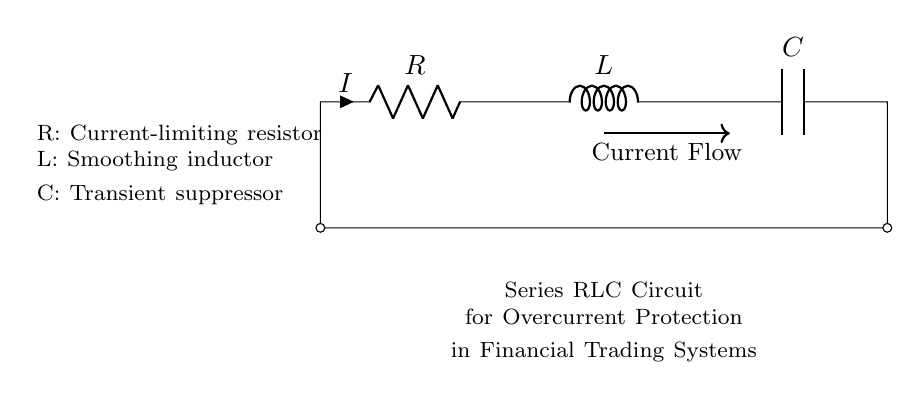What are the components in the circuit? The components are a resistor, an inductor, and a capacitor, which are indicated as R, L, and C in the circuit diagram.
Answer: Resistor, Inductor, Capacitor What is the function of the resistor in this circuit? The resistor (R) is labeled as a current-limiting resistor, which means it restricts the amount of current flowing through the circuit to prevent overcurrent conditions.
Answer: Current-limiting What is the role of the inductor in this circuit? The inductor (L) is described as a smoothing inductor, functioning to smooth out current variations and reduce ripples in the current flow.
Answer: Smoothing How does the capacitor function in this circuit? The capacitor (C) in the circuit is referred to as a transient suppressor, which helps eliminate voltage spikes and stabilize the circuit against sudden changes in current or voltage.
Answer: Transient suppressor Why is this circuit used in financial trading systems? This Series RLC circuit is used for overcurrent protection, ensuring that unexpected current surges do not damage sensitive electronic components in financial trading systems.
Answer: Overcurrent protection If the current flowing through the circuit is 2 Amps, what does that represent? The current (I) flowing through the circuit is noted as 2 Amps, which is the amount of electrical charge moving through the circuit's components, affecting their performance.
Answer: 2 Amps What type of circuit is depicted here? The circuit shown is a series RLC circuit specifically designed to work together in a specific manner, indicating all components are connected end-to-end in a single loop.
Answer: Series RLC 